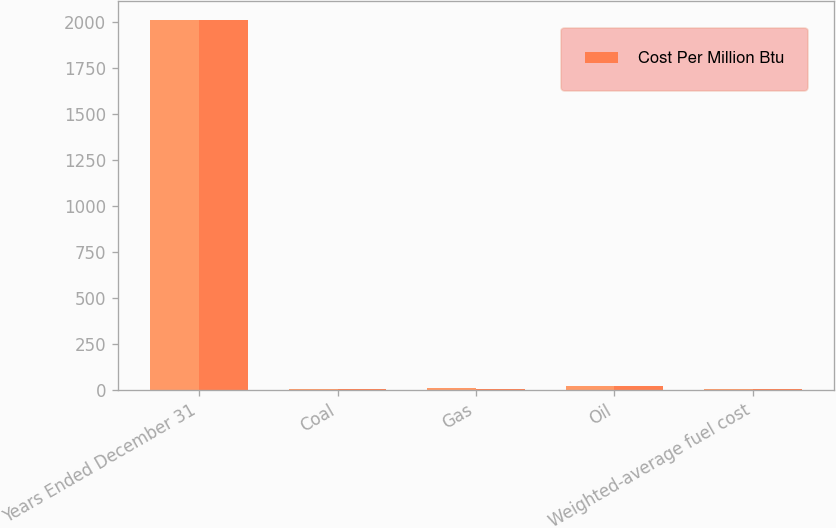Convert chart. <chart><loc_0><loc_0><loc_500><loc_500><stacked_bar_chart><ecel><fcel>Years Ended December 31<fcel>Coal<fcel>Gas<fcel>Oil<fcel>Weighted-average fuel cost<nl><fcel>nan<fcel>2014<fcel>2.72<fcel>7.19<fcel>20.16<fcel>3.17<nl><fcel>Cost Per Million Btu<fcel>2011<fcel>2.94<fcel>4.95<fcel>18.55<fcel>3.18<nl></chart> 